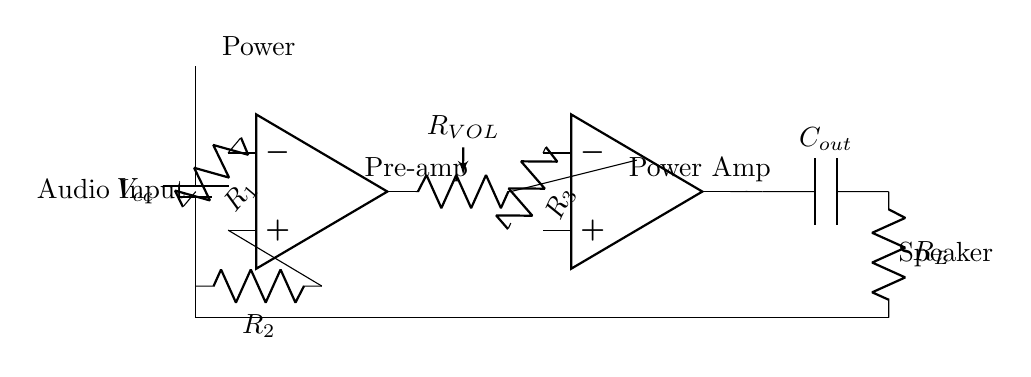What is the type of power source used in this circuit? The circuit uses a battery as the power source, identified by the symbol next to the label `Vcc` on the left side.
Answer: Battery How many resistors are present in the circuit? There are three resistors labeled `R1`, `R2`, and `R3`, each represented by the R symbol in the circuit.
Answer: Three What do the labels `R_VOL` and `R_L` indicate in this circuit? `R_VOL` represents the volume control resistor in the output stage, while `R_L` denotes the load resistor connected to the speaker.
Answer: Volume control resistor and load resistor What is the function of the capacitor `C_out`? The capacitor `C_out` is responsible for coupling the output signal to the speaker while blocking any DC component, allowing only AC signals to pass through.
Answer: Coupling AC signal What is the configuration of the operational amplifiers in this schematic? The schematic contains two operational amplifiers configured as a pre-amplifier and a power amplifier stage, optimizing audio signal amplification.
Answer: Pre-amplifier and power amplifier What are the voltage levels represented in this circuit? The circuit is designed to operate with the voltage level denoted as `Vcc`, which represents the voltage supplied by the battery to the operational amplifiers and other components.
Answer: Vcc 